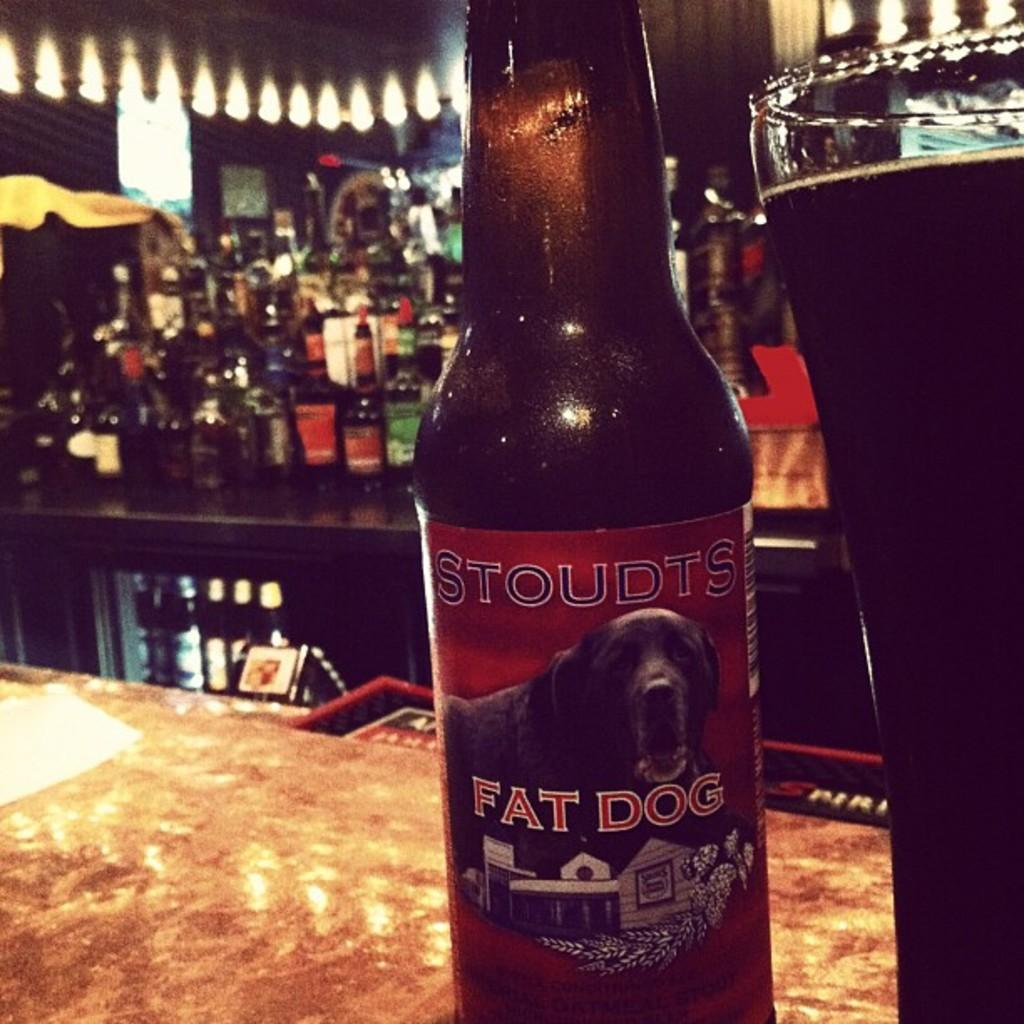<image>
Write a terse but informative summary of the picture. A beer bottle from Fat Dog on a bar counter. 